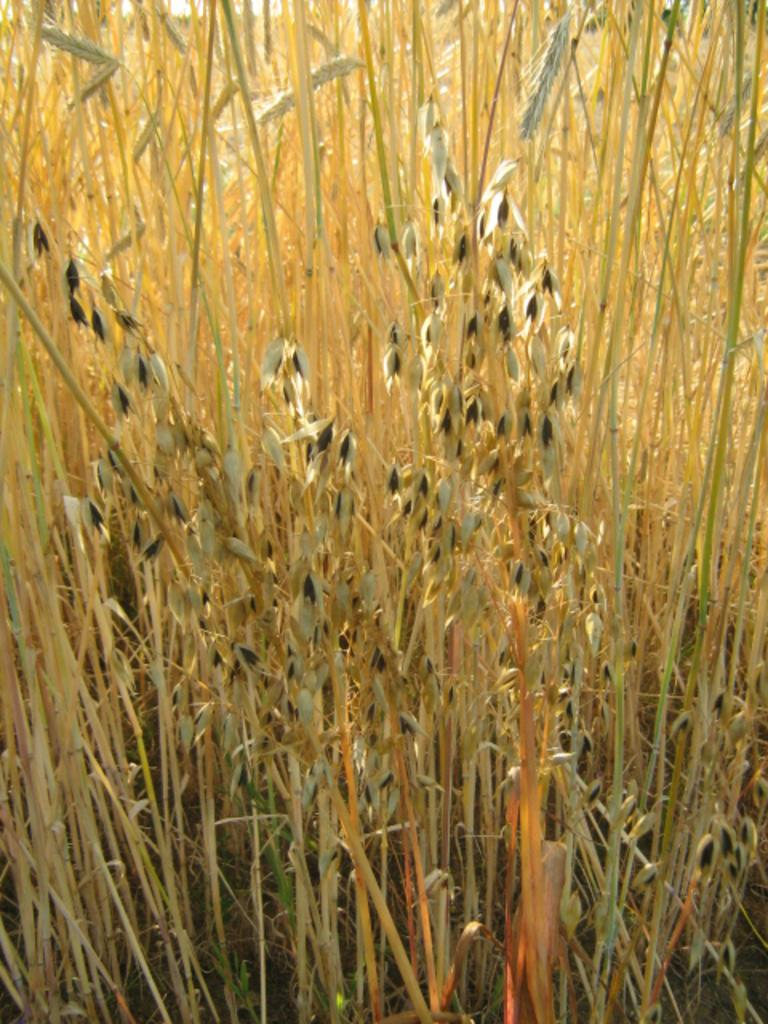What type of living organisms can be seen in the image? Plants can be seen in the image. What is the color of the plants in the image? The plants are brown in color. What else is present in the image besides the plants? There are objects in the image. What is the color of the objects in the image? The objects are black in color. How many grapes are hanging from the plants in the image? There are no grapes present in the image; the plants are brown in color. What type of slip can be seen on the objects in the image? There are no slips present in the image; the objects are black in color. 